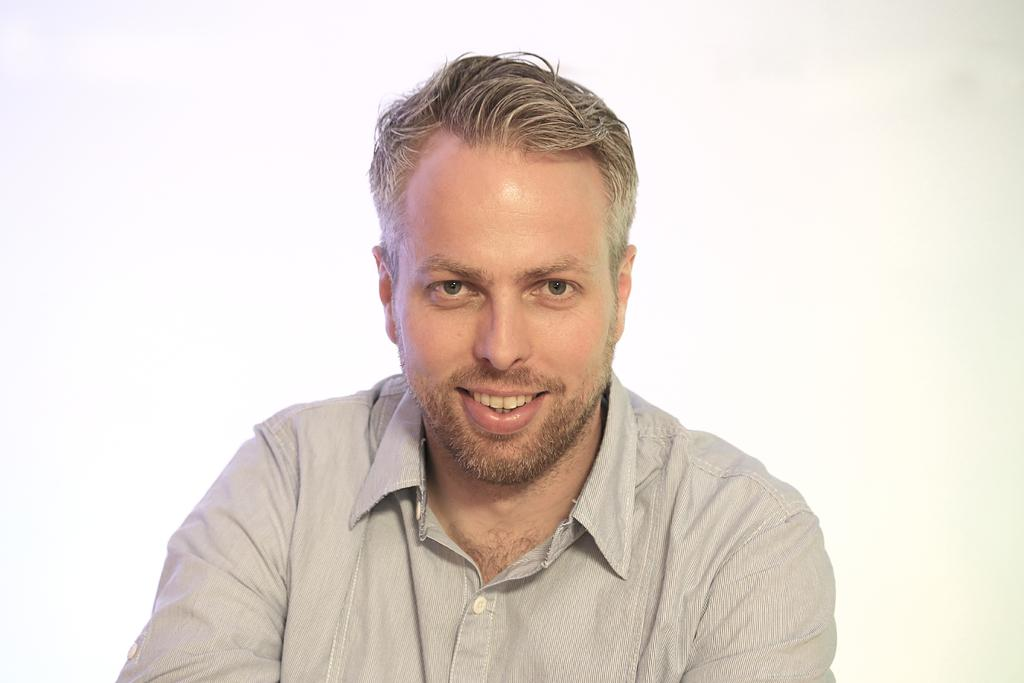Who is present in the image? There is a man in the image. What type of goat can be seen carrying a parcel in the image? There is no goat or parcel present in the image; it only features a man. 